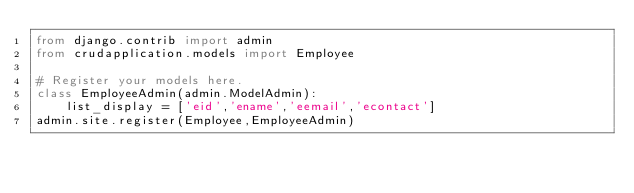<code> <loc_0><loc_0><loc_500><loc_500><_Python_>from django.contrib import admin
from crudapplication.models import Employee

# Register your models here.
class EmployeeAdmin(admin.ModelAdmin):
    list_display = ['eid','ename','eemail','econtact']
admin.site.register(Employee,EmployeeAdmin)</code> 